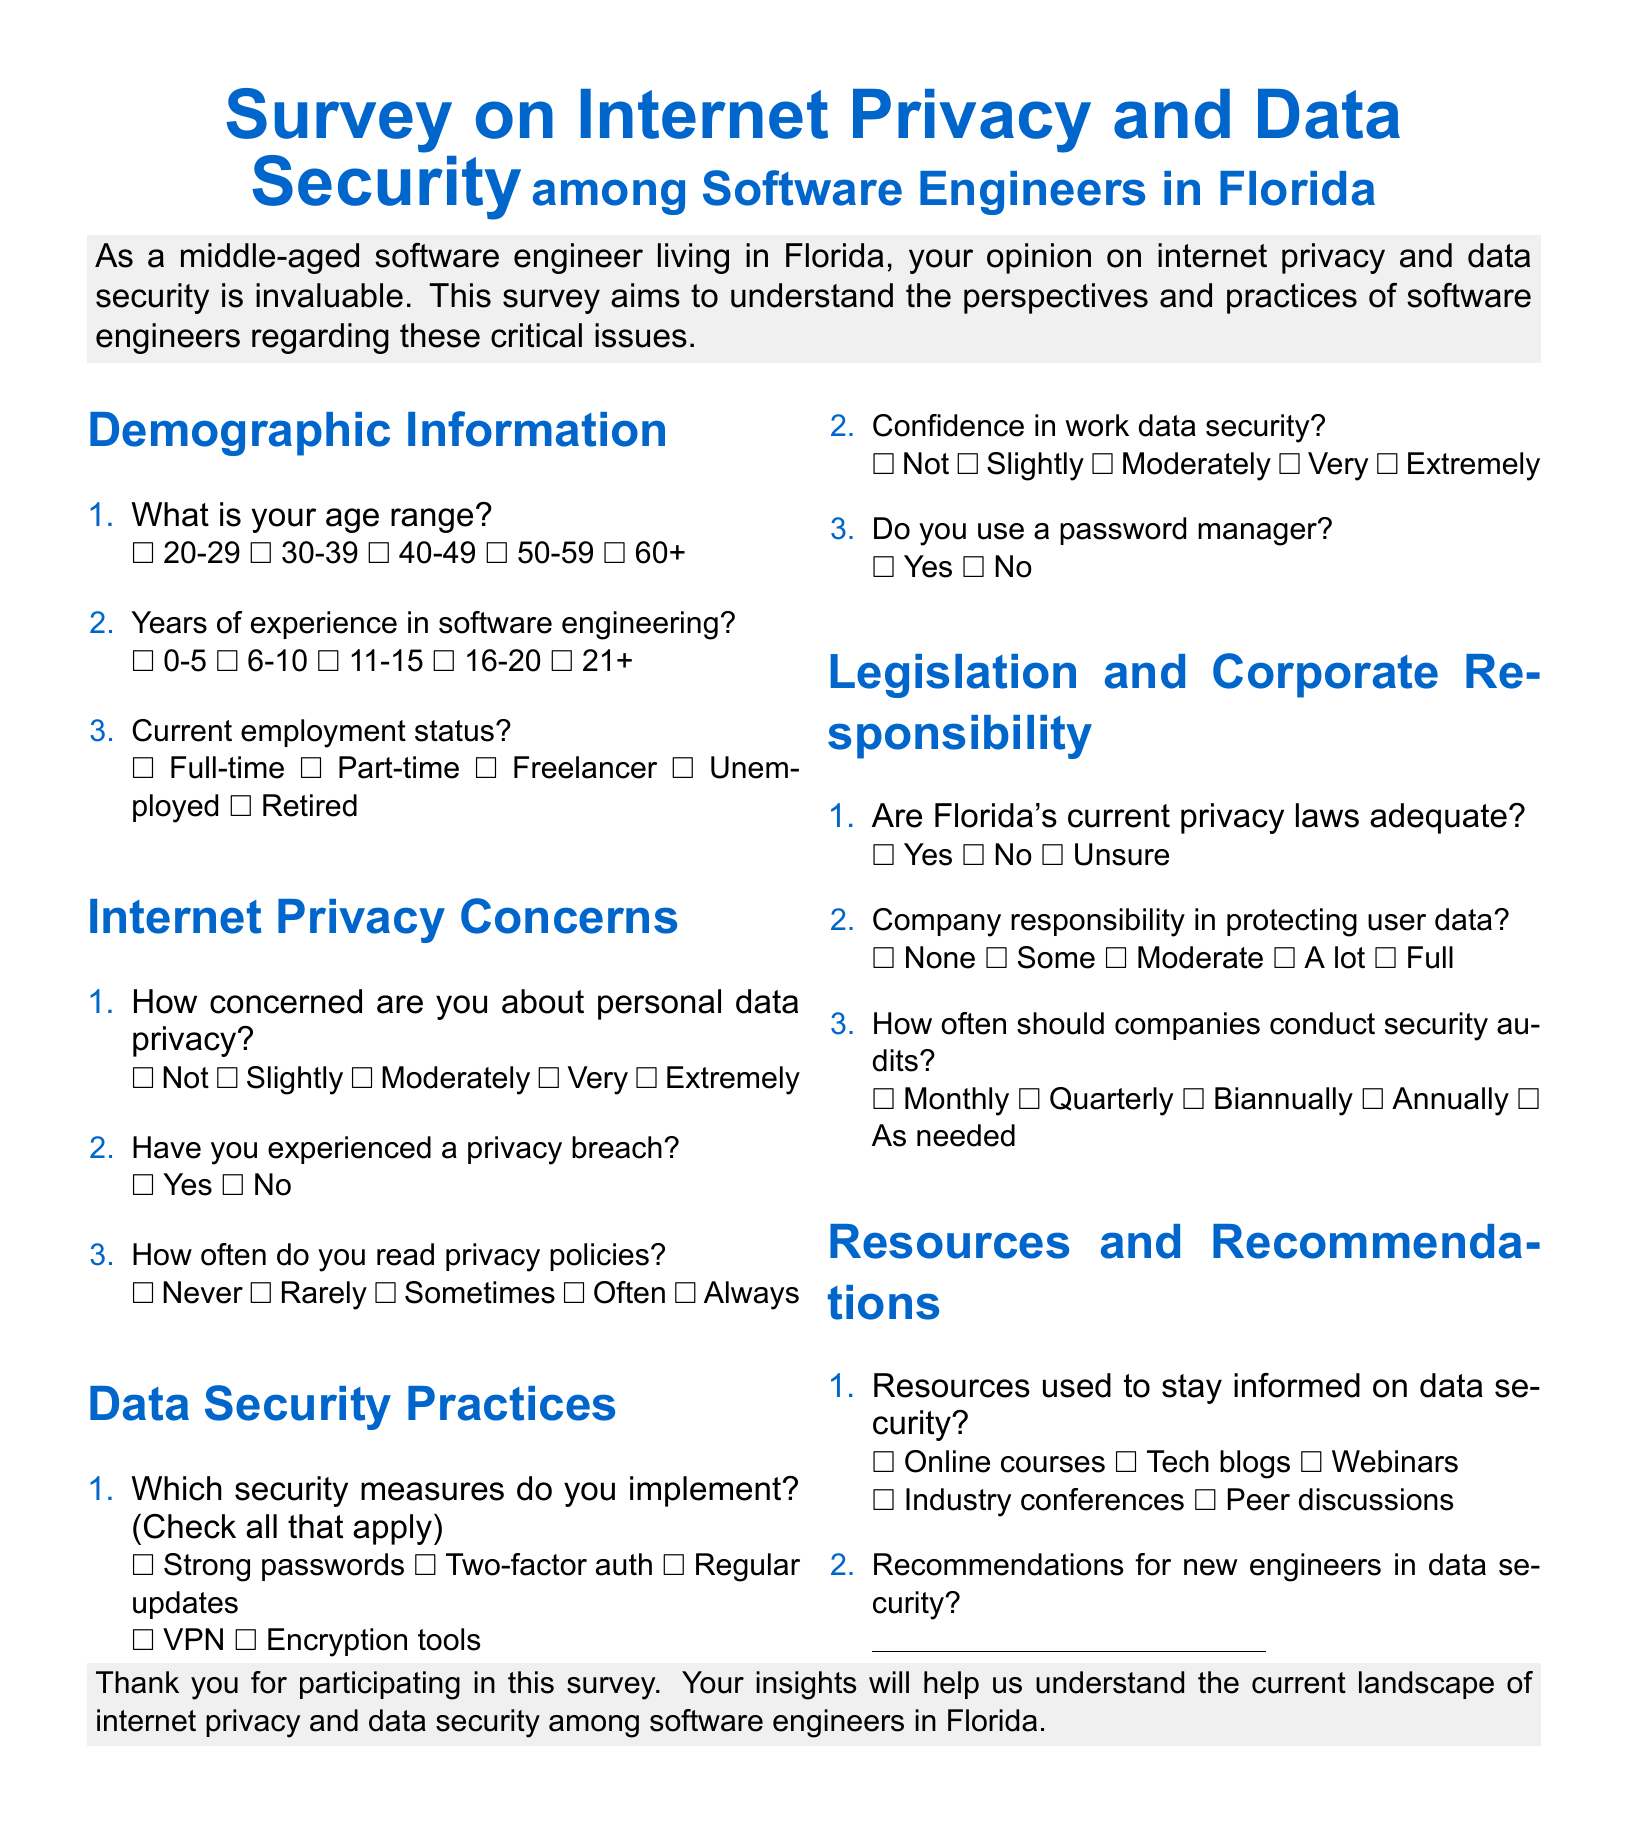What is the title of the survey? The title is provided at the beginning of the document.
Answer: Survey on Internet Privacy and Data Security Who is the target audience for this survey? The introduction specifies the target audience as software engineers living in Florida.
Answer: Software engineers in Florida How many demographic questions are included in the document? The document includes a specific section dedicated to demographic information with three questions.
Answer: 3 What is the highest level of concern regarding personal data privacy mentioned? The options for concern are listed in a specific order, indicating varying levels of concern.
Answer: Extremely What security measure is not explicitly listed in the options? The options for security measures are specified, and one common measure is implied to be missing.
Answer: Antivirus software What is the frequency of company security audits suggested in the document? The document provides multiple choice answers regarding how often companies should conduct audits.
Answer: As needed What resource type is NOT mentioned for staying informed on data security? The resources listed include specific types, identifying a type not included as a response.
Answer: Books How do respondents indicate their current employment status? Employment status is indicated through a multiple-choice format presented in the document.
Answer: Full-time (or Part-time, Freelancer, Unemployed, Retired) What is the purpose of the survey? The purpose is clearly communicated in the document's introduction.
Answer: Understand the perspectives and practices of software engineers regarding these issues 